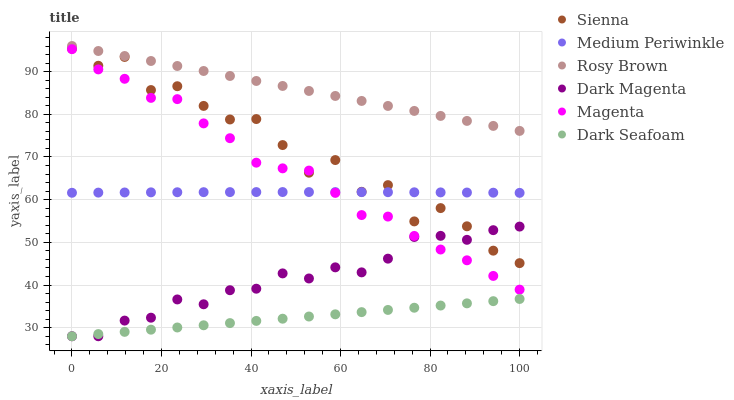Does Dark Seafoam have the minimum area under the curve?
Answer yes or no. Yes. Does Rosy Brown have the maximum area under the curve?
Answer yes or no. Yes. Does Medium Periwinkle have the minimum area under the curve?
Answer yes or no. No. Does Medium Periwinkle have the maximum area under the curve?
Answer yes or no. No. Is Dark Seafoam the smoothest?
Answer yes or no. Yes. Is Sienna the roughest?
Answer yes or no. Yes. Is Rosy Brown the smoothest?
Answer yes or no. No. Is Rosy Brown the roughest?
Answer yes or no. No. Does Dark Magenta have the lowest value?
Answer yes or no. Yes. Does Medium Periwinkle have the lowest value?
Answer yes or no. No. Does Rosy Brown have the highest value?
Answer yes or no. Yes. Does Medium Periwinkle have the highest value?
Answer yes or no. No. Is Magenta less than Rosy Brown?
Answer yes or no. Yes. Is Magenta greater than Dark Seafoam?
Answer yes or no. Yes. Does Magenta intersect Medium Periwinkle?
Answer yes or no. Yes. Is Magenta less than Medium Periwinkle?
Answer yes or no. No. Is Magenta greater than Medium Periwinkle?
Answer yes or no. No. Does Magenta intersect Rosy Brown?
Answer yes or no. No. 